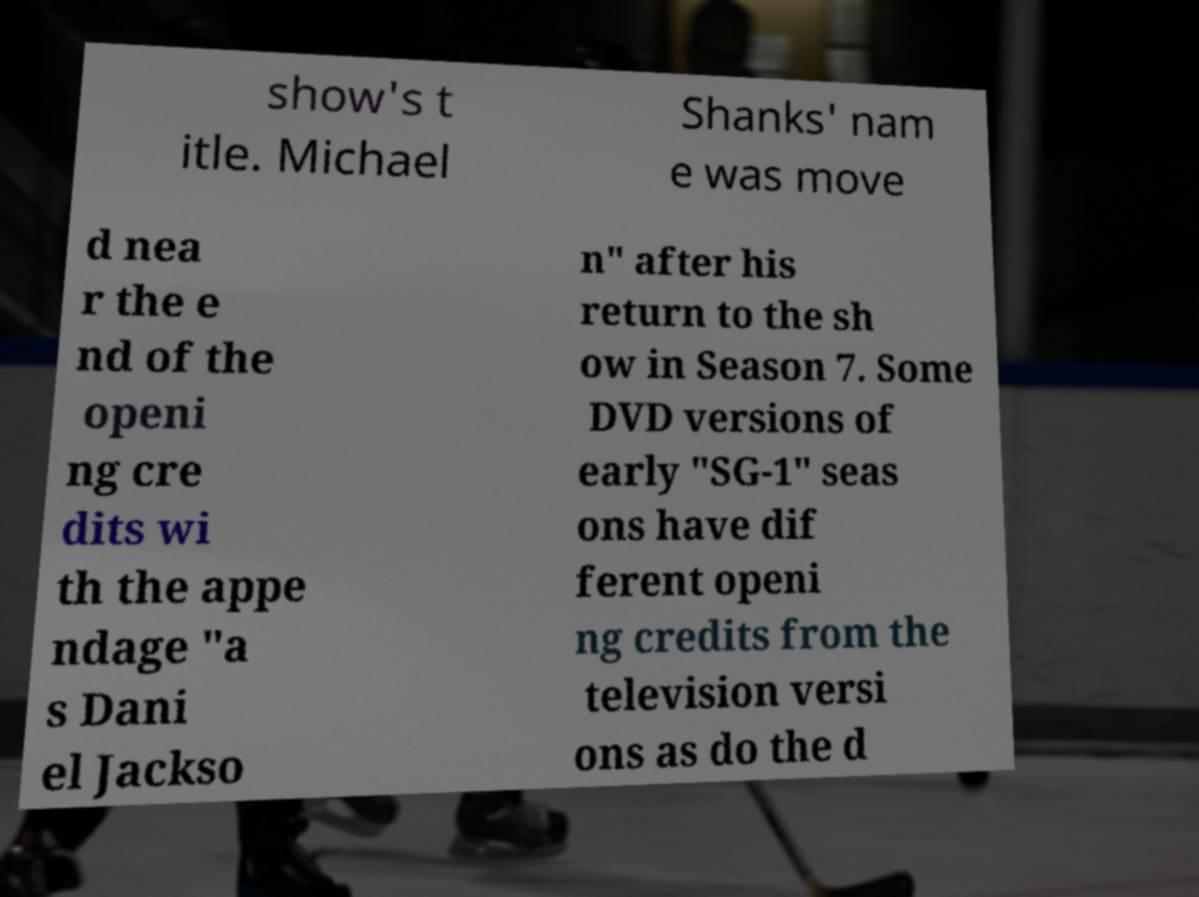For documentation purposes, I need the text within this image transcribed. Could you provide that? show's t itle. Michael Shanks' nam e was move d nea r the e nd of the openi ng cre dits wi th the appe ndage "a s Dani el Jackso n" after his return to the sh ow in Season 7. Some DVD versions of early "SG-1" seas ons have dif ferent openi ng credits from the television versi ons as do the d 